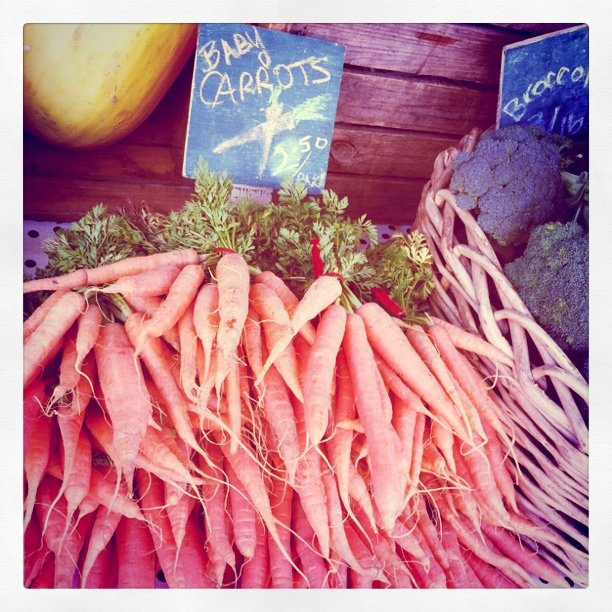<image>Are those carrots organic? It's ambiguous whether the carrots are organic or not. Are those carrots organic? I don't know if those carrots are organic. 